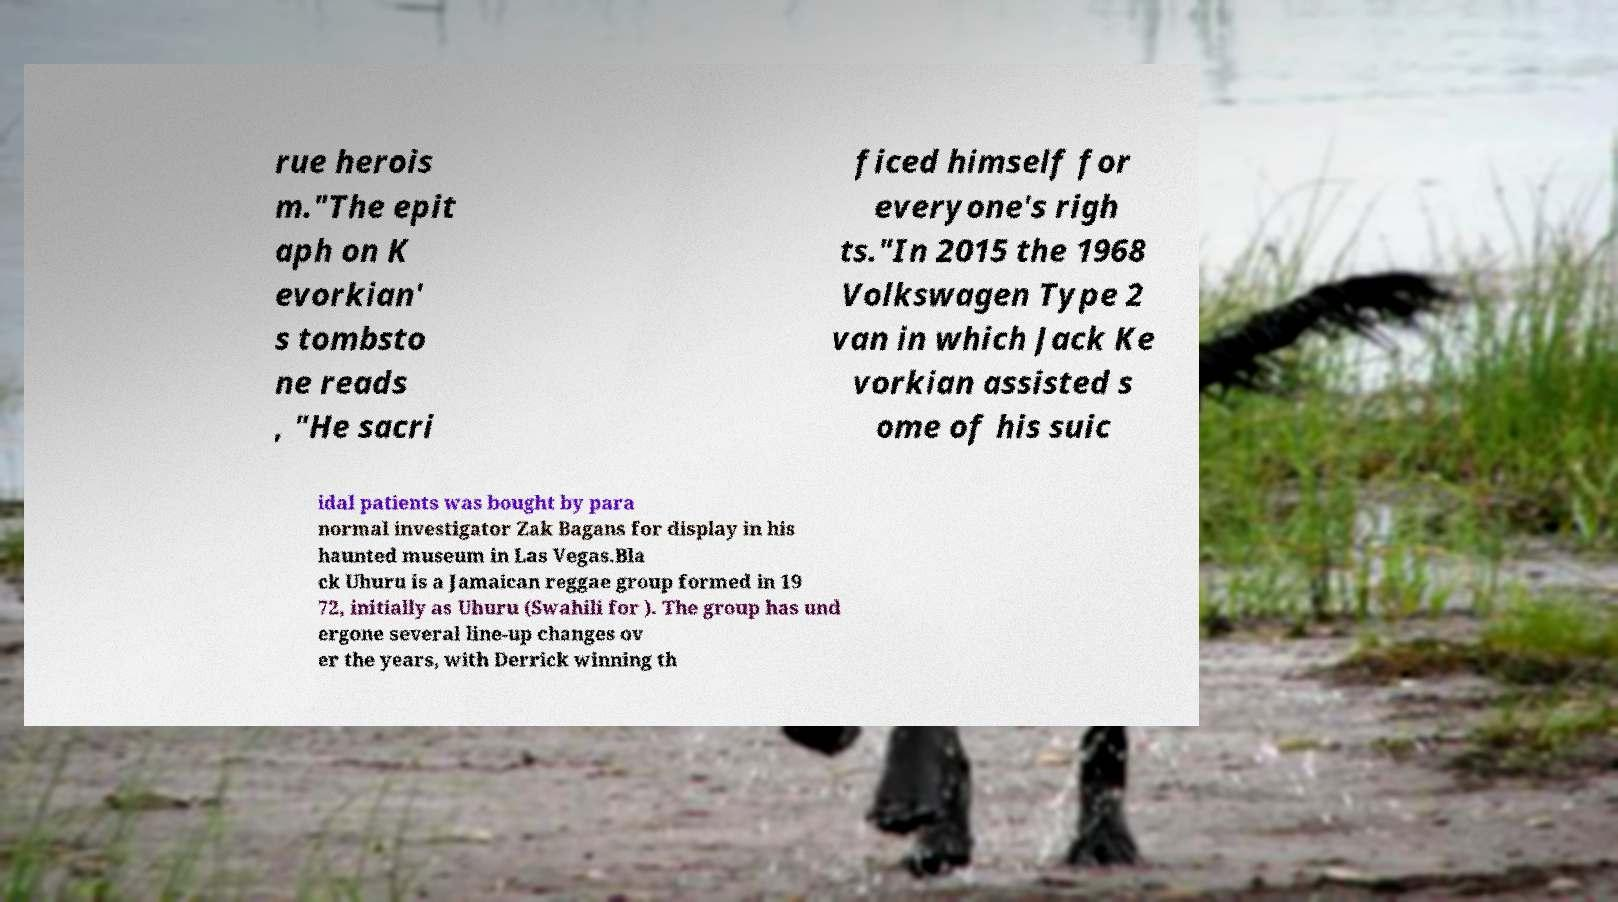Please read and relay the text visible in this image. What does it say? rue herois m."The epit aph on K evorkian' s tombsto ne reads , "He sacri ficed himself for everyone's righ ts."In 2015 the 1968 Volkswagen Type 2 van in which Jack Ke vorkian assisted s ome of his suic idal patients was bought by para normal investigator Zak Bagans for display in his haunted museum in Las Vegas.Bla ck Uhuru is a Jamaican reggae group formed in 19 72, initially as Uhuru (Swahili for ). The group has und ergone several line-up changes ov er the years, with Derrick winning th 